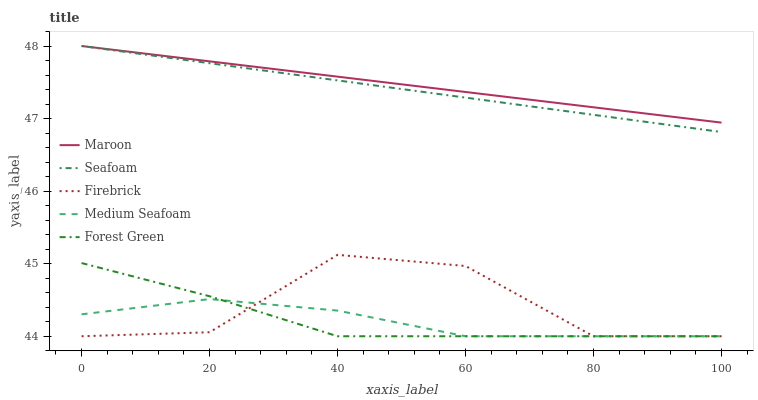Does Medium Seafoam have the minimum area under the curve?
Answer yes or no. Yes. Does Maroon have the maximum area under the curve?
Answer yes or no. Yes. Does Firebrick have the minimum area under the curve?
Answer yes or no. No. Does Firebrick have the maximum area under the curve?
Answer yes or no. No. Is Seafoam the smoothest?
Answer yes or no. Yes. Is Firebrick the roughest?
Answer yes or no. Yes. Is Firebrick the smoothest?
Answer yes or no. No. Is Seafoam the roughest?
Answer yes or no. No. Does Forest Green have the lowest value?
Answer yes or no. Yes. Does Seafoam have the lowest value?
Answer yes or no. No. Does Maroon have the highest value?
Answer yes or no. Yes. Does Firebrick have the highest value?
Answer yes or no. No. Is Firebrick less than Seafoam?
Answer yes or no. Yes. Is Seafoam greater than Forest Green?
Answer yes or no. Yes. Does Medium Seafoam intersect Firebrick?
Answer yes or no. Yes. Is Medium Seafoam less than Firebrick?
Answer yes or no. No. Is Medium Seafoam greater than Firebrick?
Answer yes or no. No. Does Firebrick intersect Seafoam?
Answer yes or no. No. 